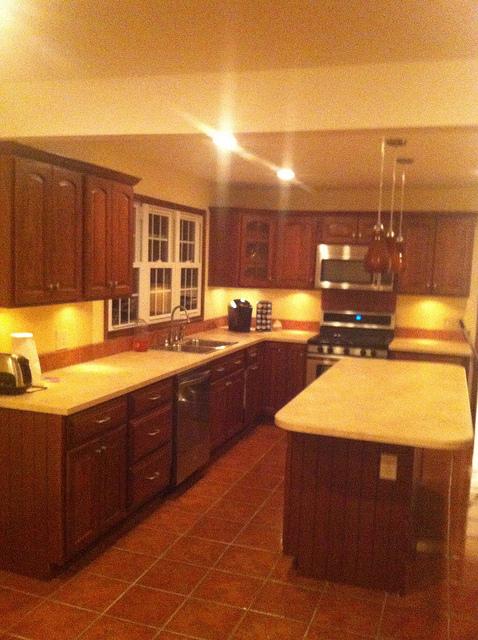What is hanging from the ceiling?
Quick response, please. Lights. Where are the pots?
Answer briefly. Cabinet. What room is this?
Write a very short answer. Kitchen. Does this kitchen contain recessed lighting?
Answer briefly. Yes. What sort of range does the oven have?
Give a very brief answer. Gas. 